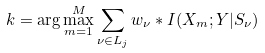Convert formula to latex. <formula><loc_0><loc_0><loc_500><loc_500>k = \arg \max _ { m = 1 } ^ { M } \sum _ { \nu \in L _ { j } } w _ { \nu } * I ( X _ { m } ; Y | S _ { \nu } )</formula> 